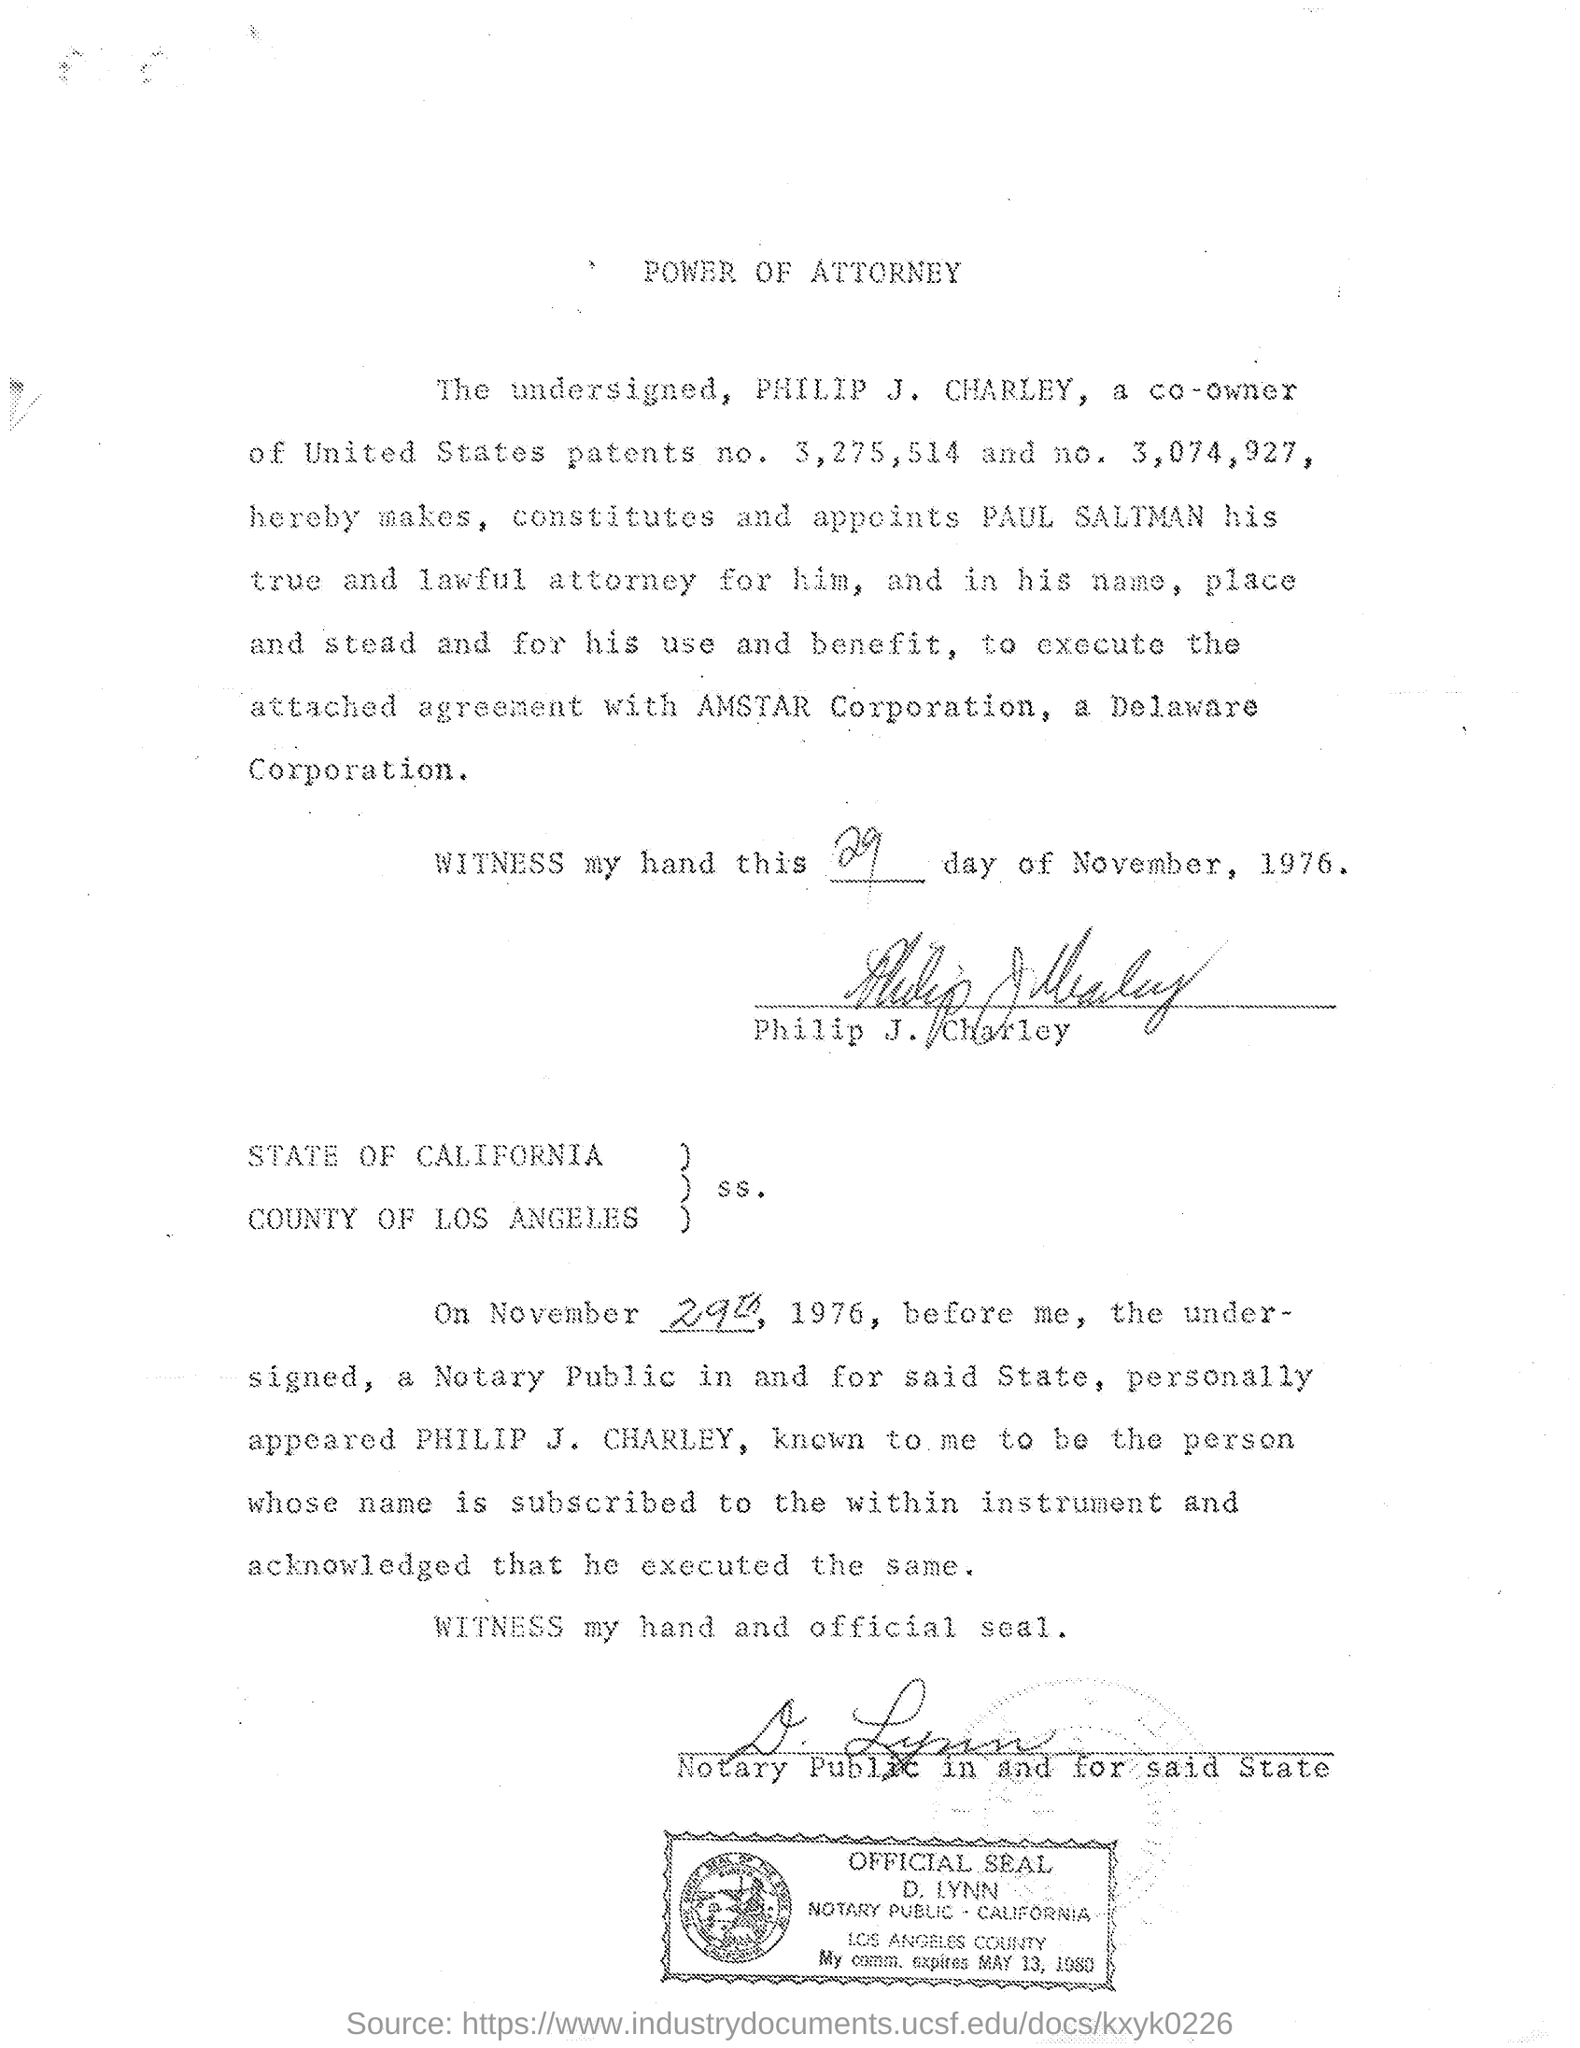On whose name power of attorney was made?
Your answer should be very brief. PAUL SALTMAN. 